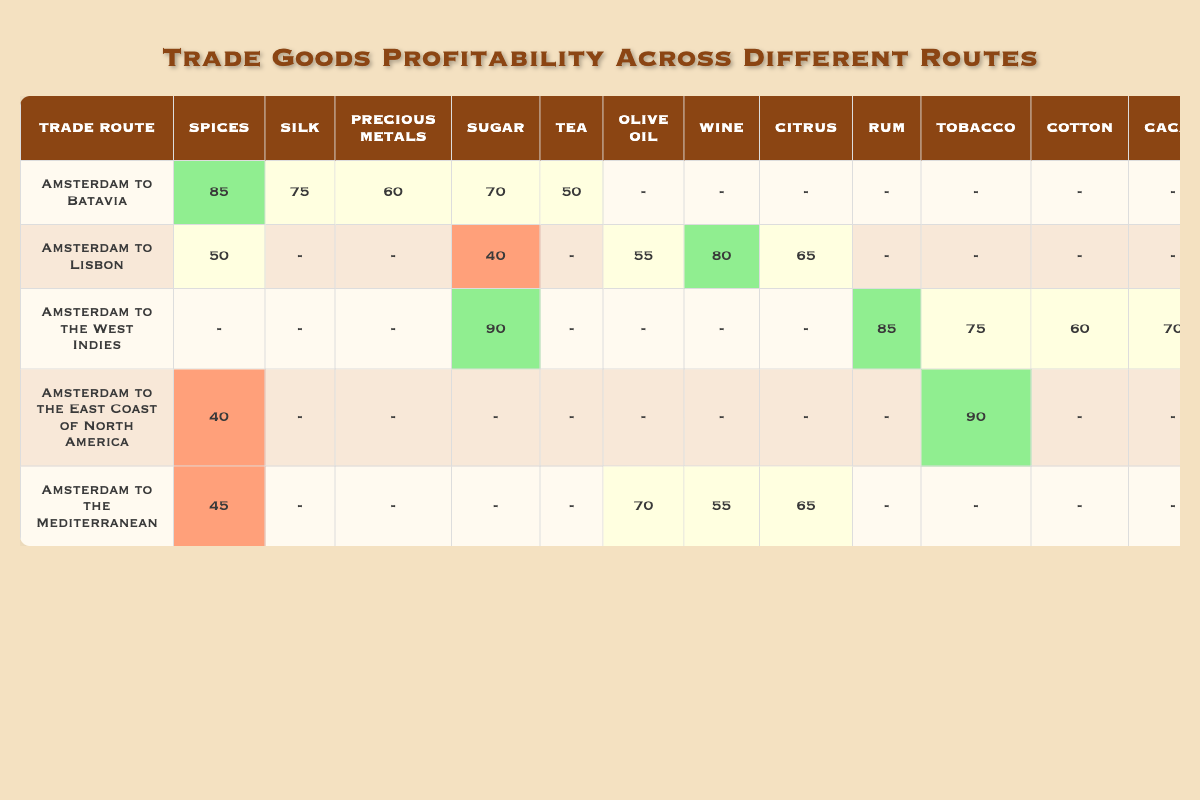What is the profitability of spices on the route from Amsterdam to Batavia? The table shows that under the route Amsterdam to Batavia, the profitability of spices is listed as 85.
Answer: 85 Which trade route has the highest profitability for sugar? The table indicates that the route from Amsterdam to the West Indies has the highest sugar profitability at 90.
Answer: Amsterdam to the West Indies Is the profitability of wine higher on the route to Lisbon than to the Mediterranean? The profitability of wine to Lisbon is 80, while to the Mediterranean it's 80 as well; thus, they are equal, not higher.
Answer: No What is the total profitability of tobacco across all routes listed? Adding the profitability of tobacco from all routes: 75 (West Indies) + 90 (East Coast) = 165. The sum is 165.
Answer: 165 On which route does olive oil show the highest profitability? The profitability for olive oil is 70 on the route to the Mediterranean, while it is not listed for other routes, making it the highest.
Answer: Amsterdam to the Mediterranean Are there any routes where silk has a profitability value? The table shows that silk is listed with a profitability of 75 only on the route to Batavia, meaning silk does appear.
Answer: Yes What is the average profitability for sugar across all routes? The values for sugar are 70 (Batavia), 40 (Lisbon), 90 (West Indies), 0 (East Coast), and 0 (Mediterranean). Their sum is 200, divided by 5, resulting in an average of 40.
Answer: 40 Which route has the lowest profitability for spices? From the table, Amsterdam to the East Coast of North America has the lowest spices profitability at 40.
Answer: Amsterdam to the East Coast of North America How does the profitability of textiles compare to that of cacao on the Mediterranean route? On the Mediterranean route, textiles are at 80 and cacao is not listed, indicating textiles have a higher or greater noted value.
Answer: Textiles are higher 